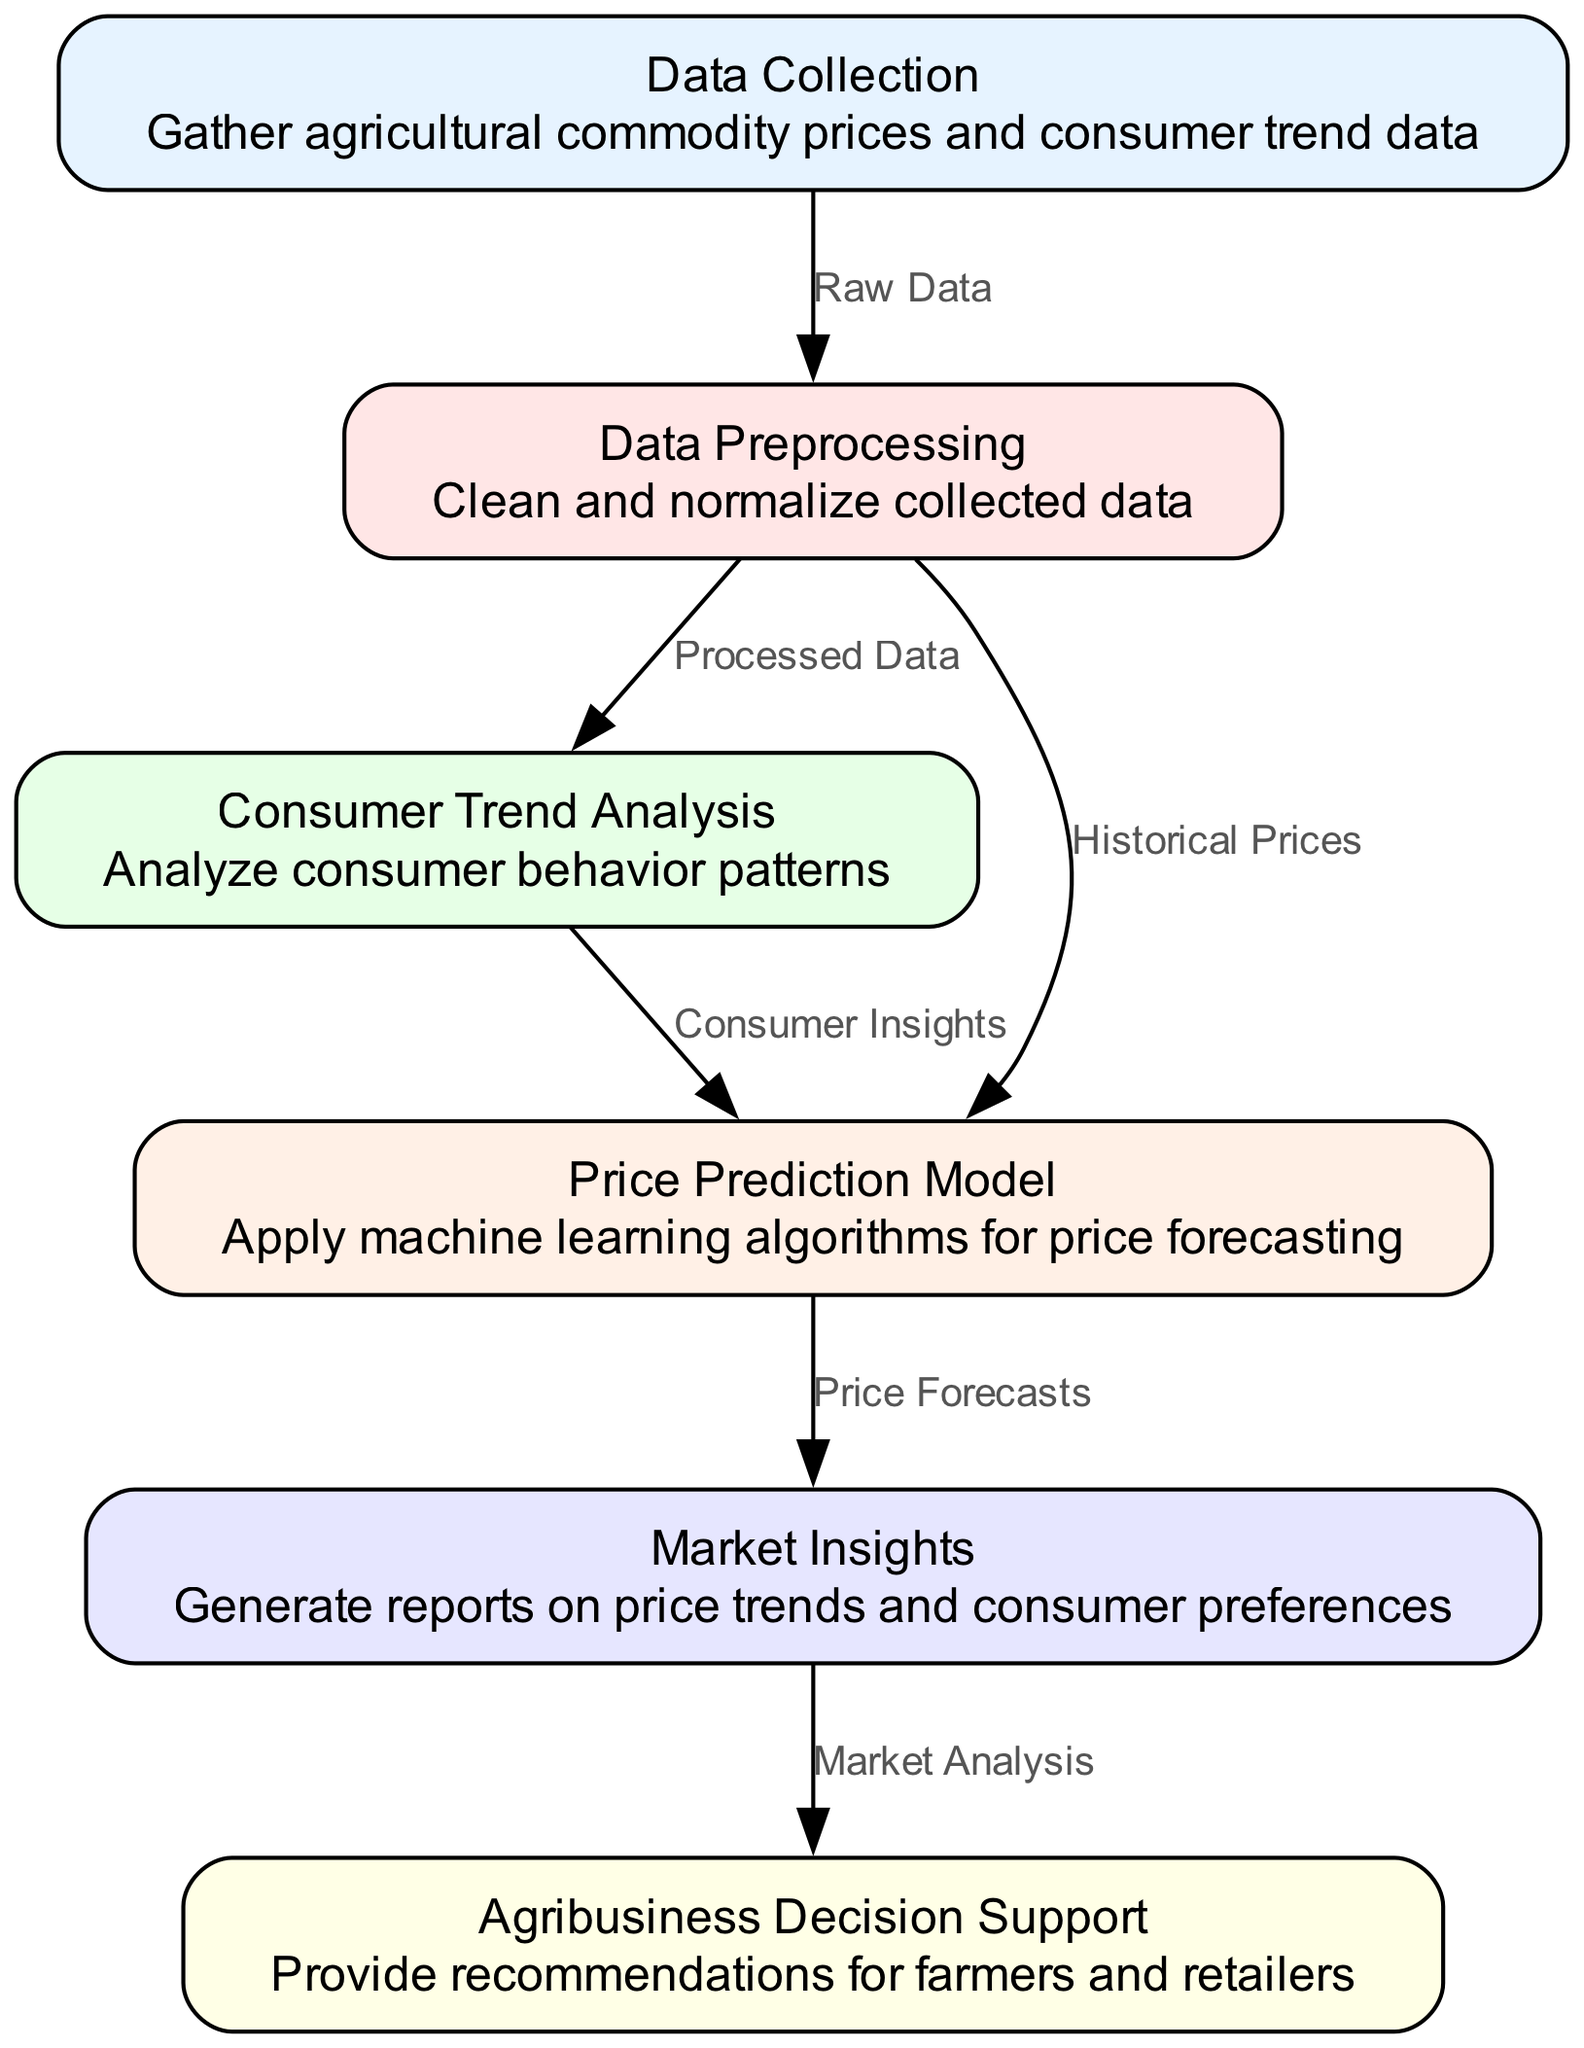What are the total number of nodes in the diagram? The diagram has 6 nodes representing different stages in the agricultural commodity price tracking system. The nodes are: Data Collection, Data Preprocessing, Consumer Trend Analysis, Price Prediction Model, Market Insights, and Agribusiness Decision Support.
Answer: 6 What is the first step in the process? The first node, according to the diagram, is "Data Collection," which is where agricultural commodity prices and consumer trend data are gathered.
Answer: Data Collection Which node follows Data Preprocessing? From the diagram, after "Data Preprocessing," the next node is "Consumer Trend Analysis," as indicated by the directed edge from node 2 to node 3.
Answer: Consumer Trend Analysis What type of data connects Data Collection to Data Preprocessing? The edge between "Data Collection" and "Data Preprocessing" is labeled "Raw Data," indicating the type of data being processed.
Answer: Raw Data How many edges are present in the diagram? The diagram displays 6 edges, each representing a relationship between the nodes, which include connections such as from Data Collection to Data Preprocessing and others.
Answer: 6 What is the relationship between Consumer Trend Analysis and Price Prediction Model? The relationship is defined by the edge from "Consumer Trend Analysis" to "Price Prediction Model," which is labeled "Consumer Insights." This indicates that insights from consumer behavior are used in price predictions.
Answer: Consumer Insights What report is generated after Price Prediction Model? Following the "Price Prediction Model," the next step is the generation of "Market Insights," which are reports based on the price forecasts.
Answer: Market Insights Which node provides recommendations for farmers and retailers? The final node in the flowchart is "Agribusiness Decision Support," which serves the purpose of providing recommendations for farmers and retailers based on market analysis.
Answer: Agribusiness Decision Support What type of analysis is done after Data Preprocessing? After "Data Preprocessing," the analysis conducted is "Consumer Trend Analysis," which involves examining consumer behavior patterns based on the processed data.
Answer: Consumer Trend Analysis 